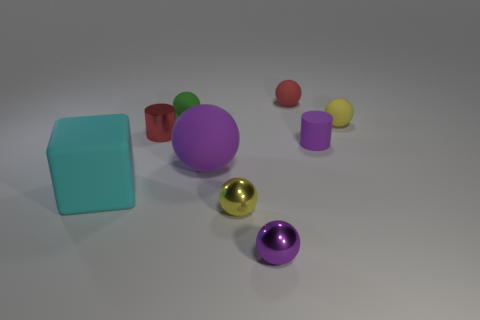Subtract all green spheres. How many spheres are left? 5 Subtract all purple spheres. How many spheres are left? 4 Subtract all red spheres. Subtract all green cylinders. How many spheres are left? 5 Add 1 big yellow things. How many objects exist? 10 Subtract all balls. How many objects are left? 3 Subtract 0 cyan balls. How many objects are left? 9 Subtract all small rubber spheres. Subtract all small red matte objects. How many objects are left? 5 Add 4 cyan things. How many cyan things are left? 5 Add 3 small gray spheres. How many small gray spheres exist? 3 